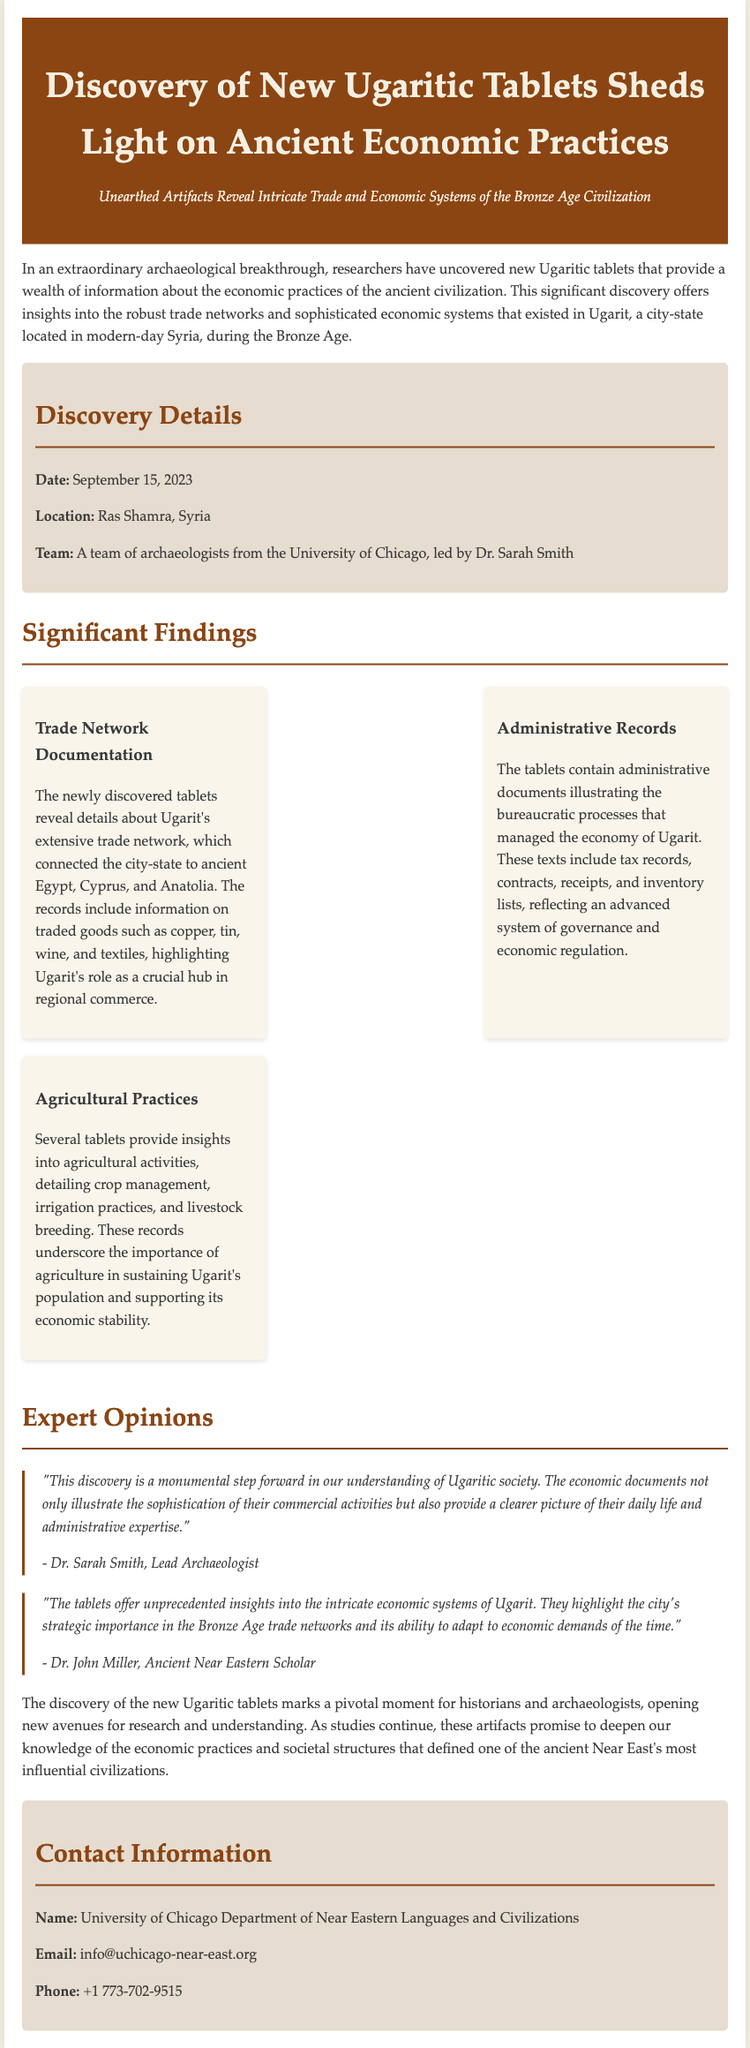what date was the discovery made? The document states that the discovery was made on September 15, 2023.
Answer: September 15, 2023 who is the lead archaeologist of the team? The lead archaeologist mentioned in the document is Dr. Sarah Smith.
Answer: Dr. Sarah Smith what location was the discovery found? The document notes that the discovery was made at Ras Shamra, Syria.
Answer: Ras Shamra, Syria what type of goods were detailed in the trade network documentation? The significant findings include traded goods such as copper, tin, wine, and textiles.
Answer: copper, tin, wine, and textiles what do the agricultural records provide insights into? The agricultural records detail crop management, irrigation practices, and livestock breeding.
Answer: crop management, irrigation practices, and livestock breeding who provided an expert opinion about the discovery? The document includes expert opinions from Dr. Sarah Smith and Dr. John Miller.
Answer: Dr. Sarah Smith and Dr. John Miller how does the discovery contribute to our understanding of Ugaritic society? The discovery illustrates the sophistication of Ugaritic commercial activities and daily life.
Answer: sophistication of commercial activities and daily life what is the contact email for inquiries related to the discovery? The contact email provided in the document is info@uchicago-near-east.org.
Answer: info@uchicago-near-east.org 